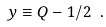Convert formula to latex. <formula><loc_0><loc_0><loc_500><loc_500>y \equiv Q - 1 / 2 \ .</formula> 